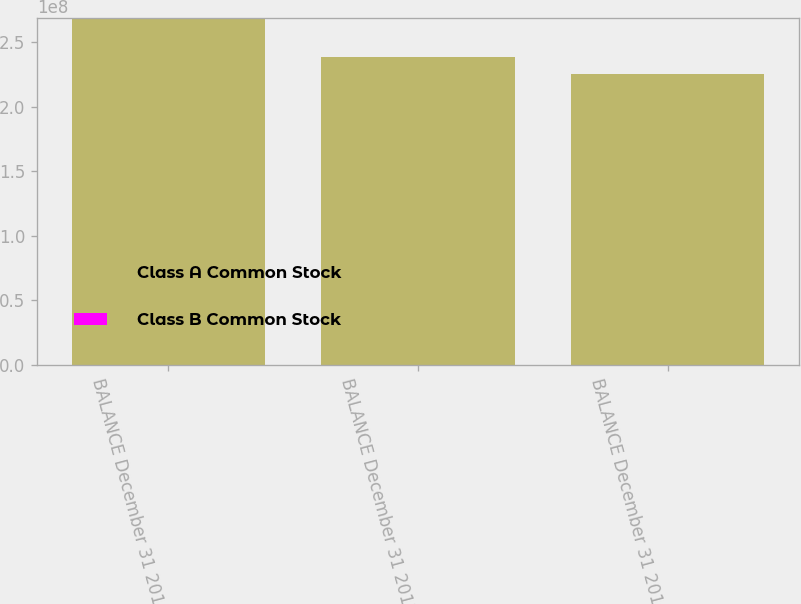<chart> <loc_0><loc_0><loc_500><loc_500><stacked_bar_chart><ecel><fcel>BALANCE December 31 2016<fcel>BALANCE December 31 2017<fcel>BALANCE December 31 2018<nl><fcel>Class A Common Stock<fcel>2.68898e+08<fcel>2.38506e+08<fcel>2.25354e+08<nl><fcel>Class B Common Stock<fcel>1<fcel>1<fcel>1<nl></chart> 